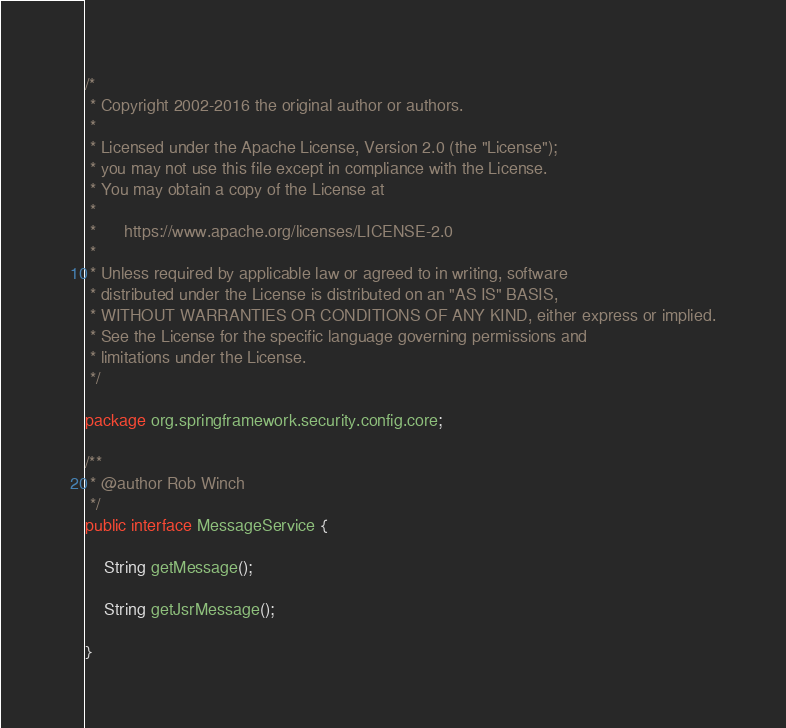Convert code to text. <code><loc_0><loc_0><loc_500><loc_500><_Java_>/*
 * Copyright 2002-2016 the original author or authors.
 *
 * Licensed under the Apache License, Version 2.0 (the "License");
 * you may not use this file except in compliance with the License.
 * You may obtain a copy of the License at
 *
 *      https://www.apache.org/licenses/LICENSE-2.0
 *
 * Unless required by applicable law or agreed to in writing, software
 * distributed under the License is distributed on an "AS IS" BASIS,
 * WITHOUT WARRANTIES OR CONDITIONS OF ANY KIND, either express or implied.
 * See the License for the specific language governing permissions and
 * limitations under the License.
 */

package org.springframework.security.config.core;

/**
 * @author Rob Winch
 */
public interface MessageService {

	String getMessage();

	String getJsrMessage();

}
</code> 